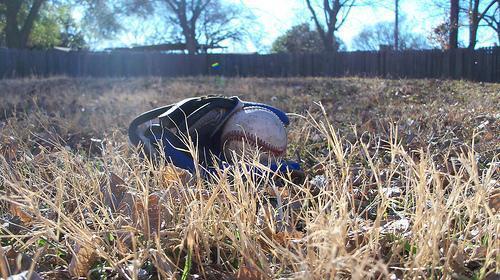How many fences are there?
Give a very brief answer. 1. How many balls are there?
Give a very brief answer. 1. How many baseballs do you see?
Give a very brief answer. 1. 